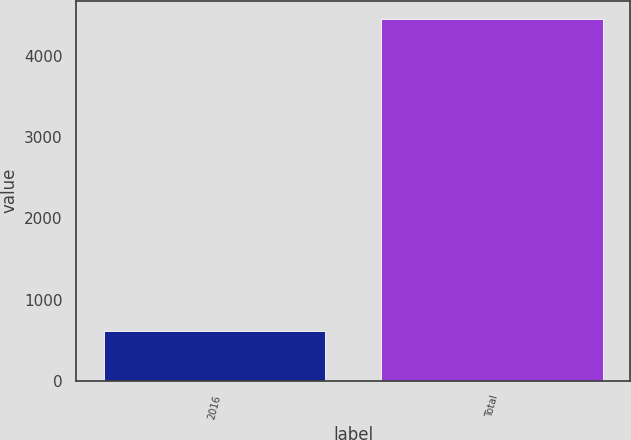Convert chart to OTSL. <chart><loc_0><loc_0><loc_500><loc_500><bar_chart><fcel>2016<fcel>Total<nl><fcel>611<fcel>4461<nl></chart> 